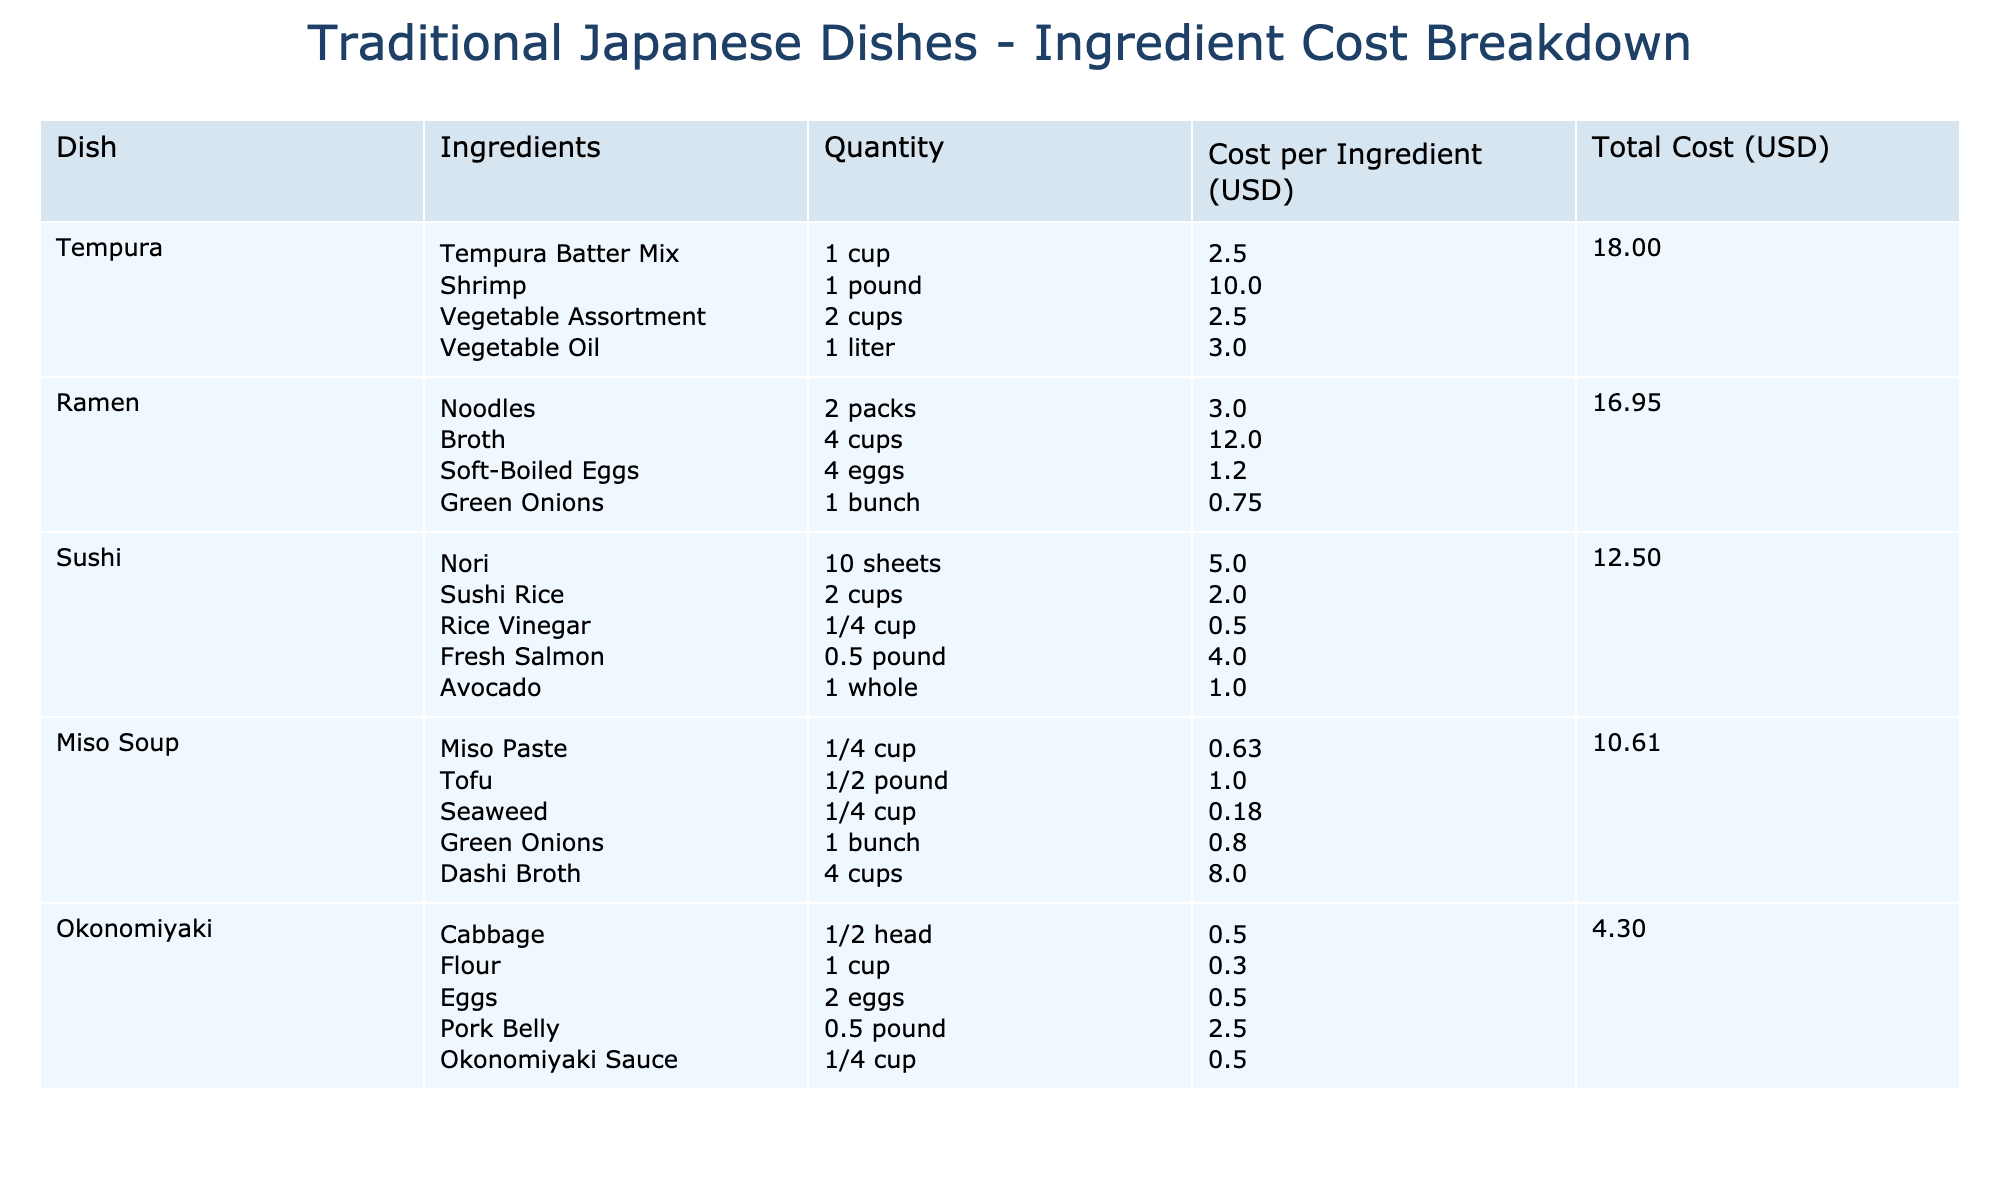What is the total cost of making Sushi? To find the total cost of making Sushi, look at the "Total Cost (USD)" column for Sushi. The costs for the ingredients are listed as: Nori (5.00), Sushi Rice (2.00), Rice Vinegar (0.50), Fresh Salmon (4.00), and Avocado (1.00). Adding these together gives 5.00 + 2.00 + 0.50 + 4.00 + 1.00 = 12.50.
Answer: 12.50 Which dish has the highest total cost? Examine the "Total Cost (USD)" column in the table and identify the maximum value. The total costs for each dish are: Sushi (12.50), Ramen (17.95), Tempura (18.00), Okonomiyaki (3.80), and Miso Soup (10.61). Ramen has the highest total cost at 17.95.
Answer: Ramen Is the cost of Nori more than the cost of Green Onions? Compare the costs listed for Nori (5.00) and Green Onions (0.75) in the "Total Cost (USD)" column. Since 5.00 is greater than 0.75, the answer is yes.
Answer: Yes What is the average cost of ingredients for Tempura? First, sum up the total costs of all Tempura ingredients: Tempura Batter Mix (2.50), Shrimp (10.00), Vegetable Assortment (2.50), and Vegetable Oil (3.00) gives 2.50 + 10.00 + 2.50 + 3.00 = 18.00. There are 4 ingredients, so divide 18.00 by 4 to get the average: 18.00 / 4 = 4.50.
Answer: 4.50 How much does it cost to make Miso Soup without Dashi Broth? Calculate the total cost excluding Dashi Broth. Miso Paste (0.63), Tofu (1.00), Seaweed (0.18), and Green Onions (0.80) gives 0.63 + 1.00 + 0.18 + 0.80 = 2.61.
Answer: 2.61 Which ingredient in Okonomiyaki has the lowest cost? Check the "Total Cost (USD)" for each ingredient in Okonomiyaki: Cabbage (0.50), Flour (0.30), Eggs (0.50), Pork Belly (2.50), and Okonomiyaki Sauce (0.50). The lowest value is for Flour at 0.30.
Answer: Flour Does Tempura require more shrimp or oil? Compare the costs of Shrimp (10.00) and Vegetable Oil (3.00). Since 10.00 is greater than 3.00, Tempura requires more shrimp than oil.
Answer: Yes What is the total cost if all ingredients for Ramen are doubled? First, list the total costs for Ramen ingredients: Noodles (3.00), Broth (12.00), Soft-Boiled Eggs (1.20), Green Onions (0.75). Doubling each gives: 3.00 * 2 = 6.00, 12.00 * 2 = 24.00, 1.20 * 2 = 2.40, and 0.75 * 2 = 1.50. The total is 6.00 + 24.00 + 2.40 + 1.50 = 34.90.
Answer: 34.90 